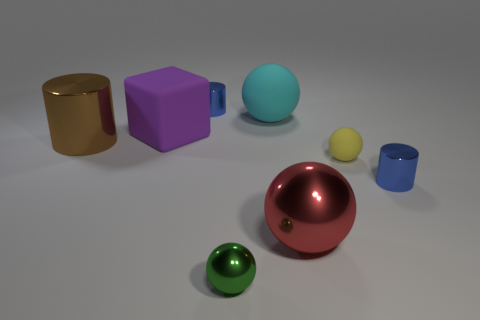Add 1 big brown spheres. How many objects exist? 9 Subtract all cylinders. How many objects are left? 5 Subtract all small blue metallic cubes. Subtract all yellow matte things. How many objects are left? 7 Add 5 small yellow rubber things. How many small yellow rubber things are left? 6 Add 3 big cyan balls. How many big cyan balls exist? 4 Subtract 1 purple cubes. How many objects are left? 7 